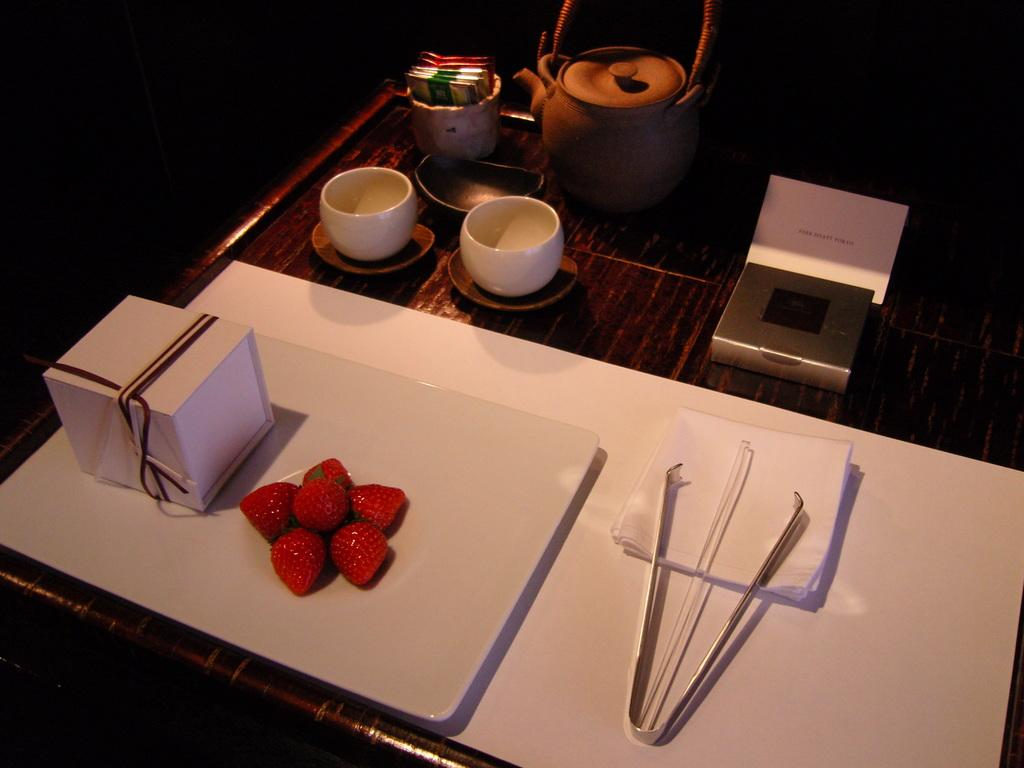What piece of furniture is present in the image? There is a table in the image. What is placed on the table? There is a kettle, cups, a box, and a tray with strawberries on the table. What might be used for heating water in the image? The kettle on the table might be used for heating water. What could be used for serving or holding food in the image? The cups and tray with strawberries on the table could be used for serving or holding food. How does the nail contribute to the comfort of the table in the image? There is no nail present in the image, and therefore it cannot contribute to the comfort of the table. 